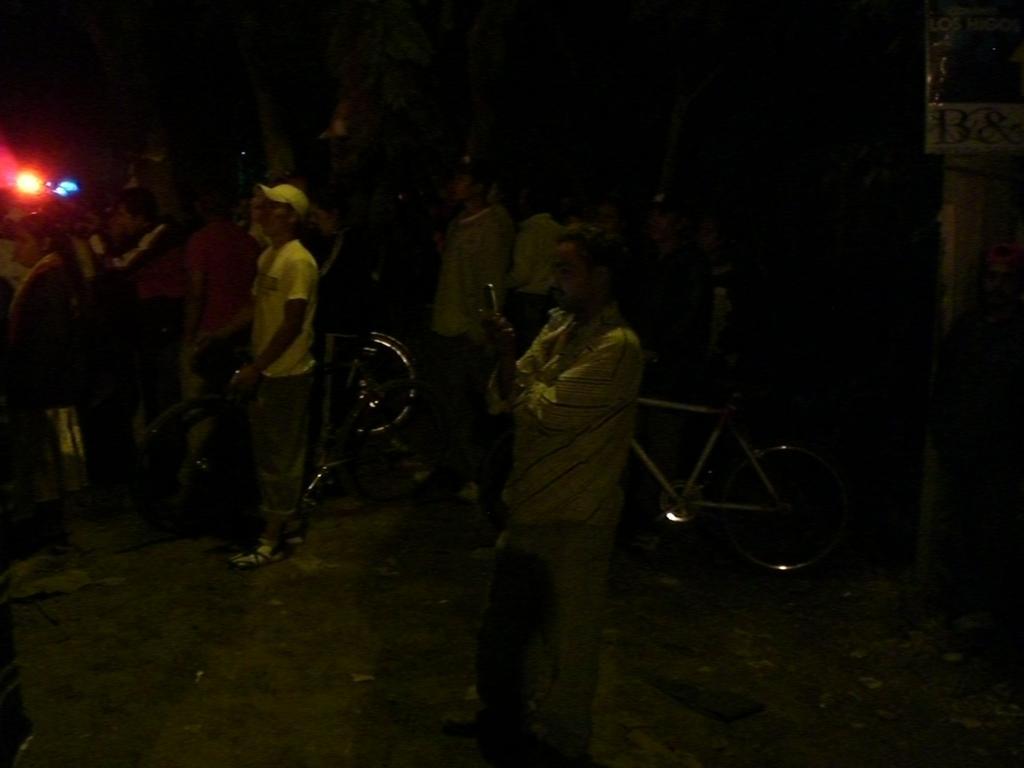Could you give a brief overview of what you see in this image? In this image we can see the people standing on the ground and there are bicycles. And we can see a light, board with text and dark background. 